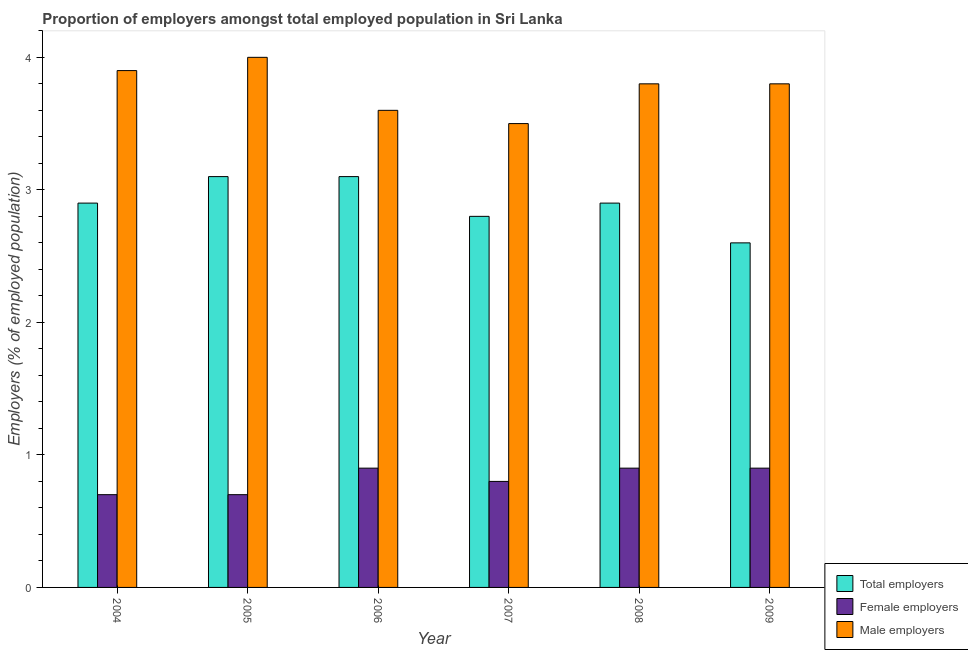How many different coloured bars are there?
Your answer should be very brief. 3. Are the number of bars on each tick of the X-axis equal?
Keep it short and to the point. Yes. How many bars are there on the 2nd tick from the left?
Provide a succinct answer. 3. What is the label of the 6th group of bars from the left?
Ensure brevity in your answer.  2009. What is the percentage of total employers in 2007?
Offer a very short reply. 2.8. Across all years, what is the maximum percentage of total employers?
Provide a short and direct response. 3.1. Across all years, what is the minimum percentage of total employers?
Your response must be concise. 2.6. In which year was the percentage of female employers maximum?
Your response must be concise. 2006. In which year was the percentage of female employers minimum?
Keep it short and to the point. 2004. What is the total percentage of male employers in the graph?
Ensure brevity in your answer.  22.6. What is the difference between the percentage of female employers in 2006 and that in 2007?
Give a very brief answer. 0.1. What is the difference between the percentage of male employers in 2007 and the percentage of female employers in 2006?
Keep it short and to the point. -0.1. What is the average percentage of male employers per year?
Provide a succinct answer. 3.77. In the year 2007, what is the difference between the percentage of female employers and percentage of male employers?
Your answer should be compact. 0. In how many years, is the percentage of total employers greater than 0.6000000000000001 %?
Give a very brief answer. 6. What is the ratio of the percentage of male employers in 2006 to that in 2009?
Provide a succinct answer. 0.95. Is the percentage of female employers in 2006 less than that in 2007?
Provide a short and direct response. No. What is the difference between the highest and the second highest percentage of male employers?
Your response must be concise. 0.1. In how many years, is the percentage of male employers greater than the average percentage of male employers taken over all years?
Your response must be concise. 4. What does the 2nd bar from the left in 2007 represents?
Your answer should be very brief. Female employers. What does the 1st bar from the right in 2006 represents?
Your response must be concise. Male employers. Are all the bars in the graph horizontal?
Ensure brevity in your answer.  No. How many years are there in the graph?
Keep it short and to the point. 6. What is the difference between two consecutive major ticks on the Y-axis?
Give a very brief answer. 1. Does the graph contain any zero values?
Your answer should be compact. No. Where does the legend appear in the graph?
Provide a short and direct response. Bottom right. How many legend labels are there?
Provide a short and direct response. 3. How are the legend labels stacked?
Ensure brevity in your answer.  Vertical. What is the title of the graph?
Make the answer very short. Proportion of employers amongst total employed population in Sri Lanka. What is the label or title of the Y-axis?
Your answer should be compact. Employers (% of employed population). What is the Employers (% of employed population) in Total employers in 2004?
Offer a very short reply. 2.9. What is the Employers (% of employed population) of Female employers in 2004?
Provide a short and direct response. 0.7. What is the Employers (% of employed population) in Male employers in 2004?
Give a very brief answer. 3.9. What is the Employers (% of employed population) in Total employers in 2005?
Your answer should be very brief. 3.1. What is the Employers (% of employed population) in Female employers in 2005?
Provide a succinct answer. 0.7. What is the Employers (% of employed population) in Male employers in 2005?
Offer a very short reply. 4. What is the Employers (% of employed population) in Total employers in 2006?
Offer a very short reply. 3.1. What is the Employers (% of employed population) in Female employers in 2006?
Make the answer very short. 0.9. What is the Employers (% of employed population) in Male employers in 2006?
Ensure brevity in your answer.  3.6. What is the Employers (% of employed population) in Total employers in 2007?
Provide a succinct answer. 2.8. What is the Employers (% of employed population) in Female employers in 2007?
Your response must be concise. 0.8. What is the Employers (% of employed population) of Total employers in 2008?
Make the answer very short. 2.9. What is the Employers (% of employed population) of Female employers in 2008?
Provide a succinct answer. 0.9. What is the Employers (% of employed population) of Male employers in 2008?
Your response must be concise. 3.8. What is the Employers (% of employed population) of Total employers in 2009?
Your answer should be compact. 2.6. What is the Employers (% of employed population) in Female employers in 2009?
Your response must be concise. 0.9. What is the Employers (% of employed population) of Male employers in 2009?
Give a very brief answer. 3.8. Across all years, what is the maximum Employers (% of employed population) in Total employers?
Offer a terse response. 3.1. Across all years, what is the maximum Employers (% of employed population) in Female employers?
Offer a very short reply. 0.9. Across all years, what is the minimum Employers (% of employed population) of Total employers?
Your answer should be very brief. 2.6. Across all years, what is the minimum Employers (% of employed population) of Female employers?
Offer a very short reply. 0.7. Across all years, what is the minimum Employers (% of employed population) in Male employers?
Keep it short and to the point. 3.5. What is the total Employers (% of employed population) of Male employers in the graph?
Ensure brevity in your answer.  22.6. What is the difference between the Employers (% of employed population) of Female employers in 2004 and that in 2005?
Offer a terse response. 0. What is the difference between the Employers (% of employed population) in Male employers in 2004 and that in 2005?
Offer a terse response. -0.1. What is the difference between the Employers (% of employed population) of Total employers in 2004 and that in 2006?
Offer a terse response. -0.2. What is the difference between the Employers (% of employed population) of Female employers in 2004 and that in 2007?
Make the answer very short. -0.1. What is the difference between the Employers (% of employed population) of Total employers in 2004 and that in 2008?
Offer a terse response. 0. What is the difference between the Employers (% of employed population) of Male employers in 2004 and that in 2008?
Ensure brevity in your answer.  0.1. What is the difference between the Employers (% of employed population) of Female employers in 2004 and that in 2009?
Your response must be concise. -0.2. What is the difference between the Employers (% of employed population) in Total employers in 2005 and that in 2006?
Keep it short and to the point. 0. What is the difference between the Employers (% of employed population) in Male employers in 2005 and that in 2006?
Offer a very short reply. 0.4. What is the difference between the Employers (% of employed population) of Total employers in 2005 and that in 2007?
Give a very brief answer. 0.3. What is the difference between the Employers (% of employed population) of Female employers in 2005 and that in 2007?
Your answer should be compact. -0.1. What is the difference between the Employers (% of employed population) in Male employers in 2005 and that in 2007?
Your answer should be very brief. 0.5. What is the difference between the Employers (% of employed population) in Total employers in 2005 and that in 2008?
Provide a short and direct response. 0.2. What is the difference between the Employers (% of employed population) of Male employers in 2005 and that in 2008?
Make the answer very short. 0.2. What is the difference between the Employers (% of employed population) of Female employers in 2005 and that in 2009?
Offer a very short reply. -0.2. What is the difference between the Employers (% of employed population) in Male employers in 2005 and that in 2009?
Ensure brevity in your answer.  0.2. What is the difference between the Employers (% of employed population) of Total employers in 2006 and that in 2007?
Ensure brevity in your answer.  0.3. What is the difference between the Employers (% of employed population) of Male employers in 2006 and that in 2007?
Ensure brevity in your answer.  0.1. What is the difference between the Employers (% of employed population) in Total employers in 2006 and that in 2008?
Your answer should be compact. 0.2. What is the difference between the Employers (% of employed population) of Male employers in 2006 and that in 2008?
Keep it short and to the point. -0.2. What is the difference between the Employers (% of employed population) in Total employers in 2006 and that in 2009?
Provide a short and direct response. 0.5. What is the difference between the Employers (% of employed population) in Male employers in 2006 and that in 2009?
Offer a very short reply. -0.2. What is the difference between the Employers (% of employed population) in Total employers in 2007 and that in 2008?
Your answer should be very brief. -0.1. What is the difference between the Employers (% of employed population) in Female employers in 2007 and that in 2008?
Offer a terse response. -0.1. What is the difference between the Employers (% of employed population) in Total employers in 2007 and that in 2009?
Make the answer very short. 0.2. What is the difference between the Employers (% of employed population) in Female employers in 2007 and that in 2009?
Your answer should be compact. -0.1. What is the difference between the Employers (% of employed population) of Male employers in 2008 and that in 2009?
Offer a very short reply. 0. What is the difference between the Employers (% of employed population) of Total employers in 2004 and the Employers (% of employed population) of Female employers in 2005?
Offer a terse response. 2.2. What is the difference between the Employers (% of employed population) of Total employers in 2004 and the Employers (% of employed population) of Male employers in 2006?
Your answer should be compact. -0.7. What is the difference between the Employers (% of employed population) of Total employers in 2004 and the Employers (% of employed population) of Female employers in 2007?
Make the answer very short. 2.1. What is the difference between the Employers (% of employed population) of Female employers in 2004 and the Employers (% of employed population) of Male employers in 2007?
Your response must be concise. -2.8. What is the difference between the Employers (% of employed population) in Total employers in 2004 and the Employers (% of employed population) in Female employers in 2008?
Your answer should be very brief. 2. What is the difference between the Employers (% of employed population) in Total employers in 2004 and the Employers (% of employed population) in Male employers in 2008?
Your answer should be compact. -0.9. What is the difference between the Employers (% of employed population) of Female employers in 2004 and the Employers (% of employed population) of Male employers in 2008?
Ensure brevity in your answer.  -3.1. What is the difference between the Employers (% of employed population) in Total employers in 2004 and the Employers (% of employed population) in Female employers in 2009?
Provide a short and direct response. 2. What is the difference between the Employers (% of employed population) of Female employers in 2005 and the Employers (% of employed population) of Male employers in 2006?
Offer a very short reply. -2.9. What is the difference between the Employers (% of employed population) in Total employers in 2005 and the Employers (% of employed population) in Female employers in 2007?
Make the answer very short. 2.3. What is the difference between the Employers (% of employed population) of Total employers in 2005 and the Employers (% of employed population) of Male employers in 2007?
Make the answer very short. -0.4. What is the difference between the Employers (% of employed population) in Total employers in 2005 and the Employers (% of employed population) in Female employers in 2009?
Give a very brief answer. 2.2. What is the difference between the Employers (% of employed population) in Total employers in 2005 and the Employers (% of employed population) in Male employers in 2009?
Give a very brief answer. -0.7. What is the difference between the Employers (% of employed population) in Female employers in 2005 and the Employers (% of employed population) in Male employers in 2009?
Provide a short and direct response. -3.1. What is the difference between the Employers (% of employed population) of Total employers in 2006 and the Employers (% of employed population) of Female employers in 2008?
Keep it short and to the point. 2.2. What is the difference between the Employers (% of employed population) in Total employers in 2006 and the Employers (% of employed population) in Male employers in 2008?
Make the answer very short. -0.7. What is the difference between the Employers (% of employed population) of Female employers in 2006 and the Employers (% of employed population) of Male employers in 2008?
Your answer should be compact. -2.9. What is the difference between the Employers (% of employed population) of Total employers in 2006 and the Employers (% of employed population) of Male employers in 2009?
Give a very brief answer. -0.7. What is the difference between the Employers (% of employed population) in Female employers in 2006 and the Employers (% of employed population) in Male employers in 2009?
Ensure brevity in your answer.  -2.9. What is the difference between the Employers (% of employed population) in Total employers in 2007 and the Employers (% of employed population) in Female employers in 2008?
Your answer should be very brief. 1.9. What is the difference between the Employers (% of employed population) in Female employers in 2007 and the Employers (% of employed population) in Male employers in 2008?
Provide a short and direct response. -3. What is the difference between the Employers (% of employed population) of Total employers in 2007 and the Employers (% of employed population) of Male employers in 2009?
Provide a succinct answer. -1. What is the difference between the Employers (% of employed population) in Total employers in 2008 and the Employers (% of employed population) in Female employers in 2009?
Offer a terse response. 2. What is the average Employers (% of employed population) in Female employers per year?
Provide a short and direct response. 0.82. What is the average Employers (% of employed population) of Male employers per year?
Your answer should be very brief. 3.77. In the year 2004, what is the difference between the Employers (% of employed population) in Female employers and Employers (% of employed population) in Male employers?
Ensure brevity in your answer.  -3.2. In the year 2005, what is the difference between the Employers (% of employed population) in Total employers and Employers (% of employed population) in Male employers?
Keep it short and to the point. -0.9. In the year 2005, what is the difference between the Employers (% of employed population) in Female employers and Employers (% of employed population) in Male employers?
Your answer should be very brief. -3.3. In the year 2006, what is the difference between the Employers (% of employed population) of Total employers and Employers (% of employed population) of Female employers?
Offer a terse response. 2.2. In the year 2007, what is the difference between the Employers (% of employed population) in Total employers and Employers (% of employed population) in Female employers?
Make the answer very short. 2. In the year 2007, what is the difference between the Employers (% of employed population) in Total employers and Employers (% of employed population) in Male employers?
Provide a succinct answer. -0.7. In the year 2008, what is the difference between the Employers (% of employed population) in Female employers and Employers (% of employed population) in Male employers?
Ensure brevity in your answer.  -2.9. In the year 2009, what is the difference between the Employers (% of employed population) in Total employers and Employers (% of employed population) in Male employers?
Your answer should be very brief. -1.2. What is the ratio of the Employers (% of employed population) of Total employers in 2004 to that in 2005?
Ensure brevity in your answer.  0.94. What is the ratio of the Employers (% of employed population) in Female employers in 2004 to that in 2005?
Give a very brief answer. 1. What is the ratio of the Employers (% of employed population) in Total employers in 2004 to that in 2006?
Provide a succinct answer. 0.94. What is the ratio of the Employers (% of employed population) of Female employers in 2004 to that in 2006?
Make the answer very short. 0.78. What is the ratio of the Employers (% of employed population) in Total employers in 2004 to that in 2007?
Ensure brevity in your answer.  1.04. What is the ratio of the Employers (% of employed population) of Female employers in 2004 to that in 2007?
Offer a terse response. 0.88. What is the ratio of the Employers (% of employed population) in Male employers in 2004 to that in 2007?
Your response must be concise. 1.11. What is the ratio of the Employers (% of employed population) in Total employers in 2004 to that in 2008?
Give a very brief answer. 1. What is the ratio of the Employers (% of employed population) in Female employers in 2004 to that in 2008?
Provide a succinct answer. 0.78. What is the ratio of the Employers (% of employed population) of Male employers in 2004 to that in 2008?
Ensure brevity in your answer.  1.03. What is the ratio of the Employers (% of employed population) in Total employers in 2004 to that in 2009?
Your answer should be compact. 1.12. What is the ratio of the Employers (% of employed population) of Male employers in 2004 to that in 2009?
Make the answer very short. 1.03. What is the ratio of the Employers (% of employed population) of Total employers in 2005 to that in 2007?
Your answer should be very brief. 1.11. What is the ratio of the Employers (% of employed population) of Male employers in 2005 to that in 2007?
Provide a succinct answer. 1.14. What is the ratio of the Employers (% of employed population) in Total employers in 2005 to that in 2008?
Give a very brief answer. 1.07. What is the ratio of the Employers (% of employed population) in Male employers in 2005 to that in 2008?
Ensure brevity in your answer.  1.05. What is the ratio of the Employers (% of employed population) of Total employers in 2005 to that in 2009?
Give a very brief answer. 1.19. What is the ratio of the Employers (% of employed population) in Female employers in 2005 to that in 2009?
Your answer should be compact. 0.78. What is the ratio of the Employers (% of employed population) in Male employers in 2005 to that in 2009?
Give a very brief answer. 1.05. What is the ratio of the Employers (% of employed population) of Total employers in 2006 to that in 2007?
Offer a very short reply. 1.11. What is the ratio of the Employers (% of employed population) in Female employers in 2006 to that in 2007?
Your response must be concise. 1.12. What is the ratio of the Employers (% of employed population) of Male employers in 2006 to that in 2007?
Provide a short and direct response. 1.03. What is the ratio of the Employers (% of employed population) of Total employers in 2006 to that in 2008?
Offer a very short reply. 1.07. What is the ratio of the Employers (% of employed population) in Female employers in 2006 to that in 2008?
Provide a short and direct response. 1. What is the ratio of the Employers (% of employed population) in Male employers in 2006 to that in 2008?
Your answer should be compact. 0.95. What is the ratio of the Employers (% of employed population) of Total employers in 2006 to that in 2009?
Your answer should be compact. 1.19. What is the ratio of the Employers (% of employed population) of Female employers in 2006 to that in 2009?
Make the answer very short. 1. What is the ratio of the Employers (% of employed population) of Male employers in 2006 to that in 2009?
Keep it short and to the point. 0.95. What is the ratio of the Employers (% of employed population) in Total employers in 2007 to that in 2008?
Ensure brevity in your answer.  0.97. What is the ratio of the Employers (% of employed population) of Female employers in 2007 to that in 2008?
Give a very brief answer. 0.89. What is the ratio of the Employers (% of employed population) in Male employers in 2007 to that in 2008?
Make the answer very short. 0.92. What is the ratio of the Employers (% of employed population) of Female employers in 2007 to that in 2009?
Ensure brevity in your answer.  0.89. What is the ratio of the Employers (% of employed population) in Male employers in 2007 to that in 2009?
Provide a short and direct response. 0.92. What is the ratio of the Employers (% of employed population) in Total employers in 2008 to that in 2009?
Keep it short and to the point. 1.12. What is the difference between the highest and the second highest Employers (% of employed population) in Male employers?
Offer a terse response. 0.1. What is the difference between the highest and the lowest Employers (% of employed population) in Total employers?
Offer a terse response. 0.5. What is the difference between the highest and the lowest Employers (% of employed population) in Male employers?
Offer a terse response. 0.5. 